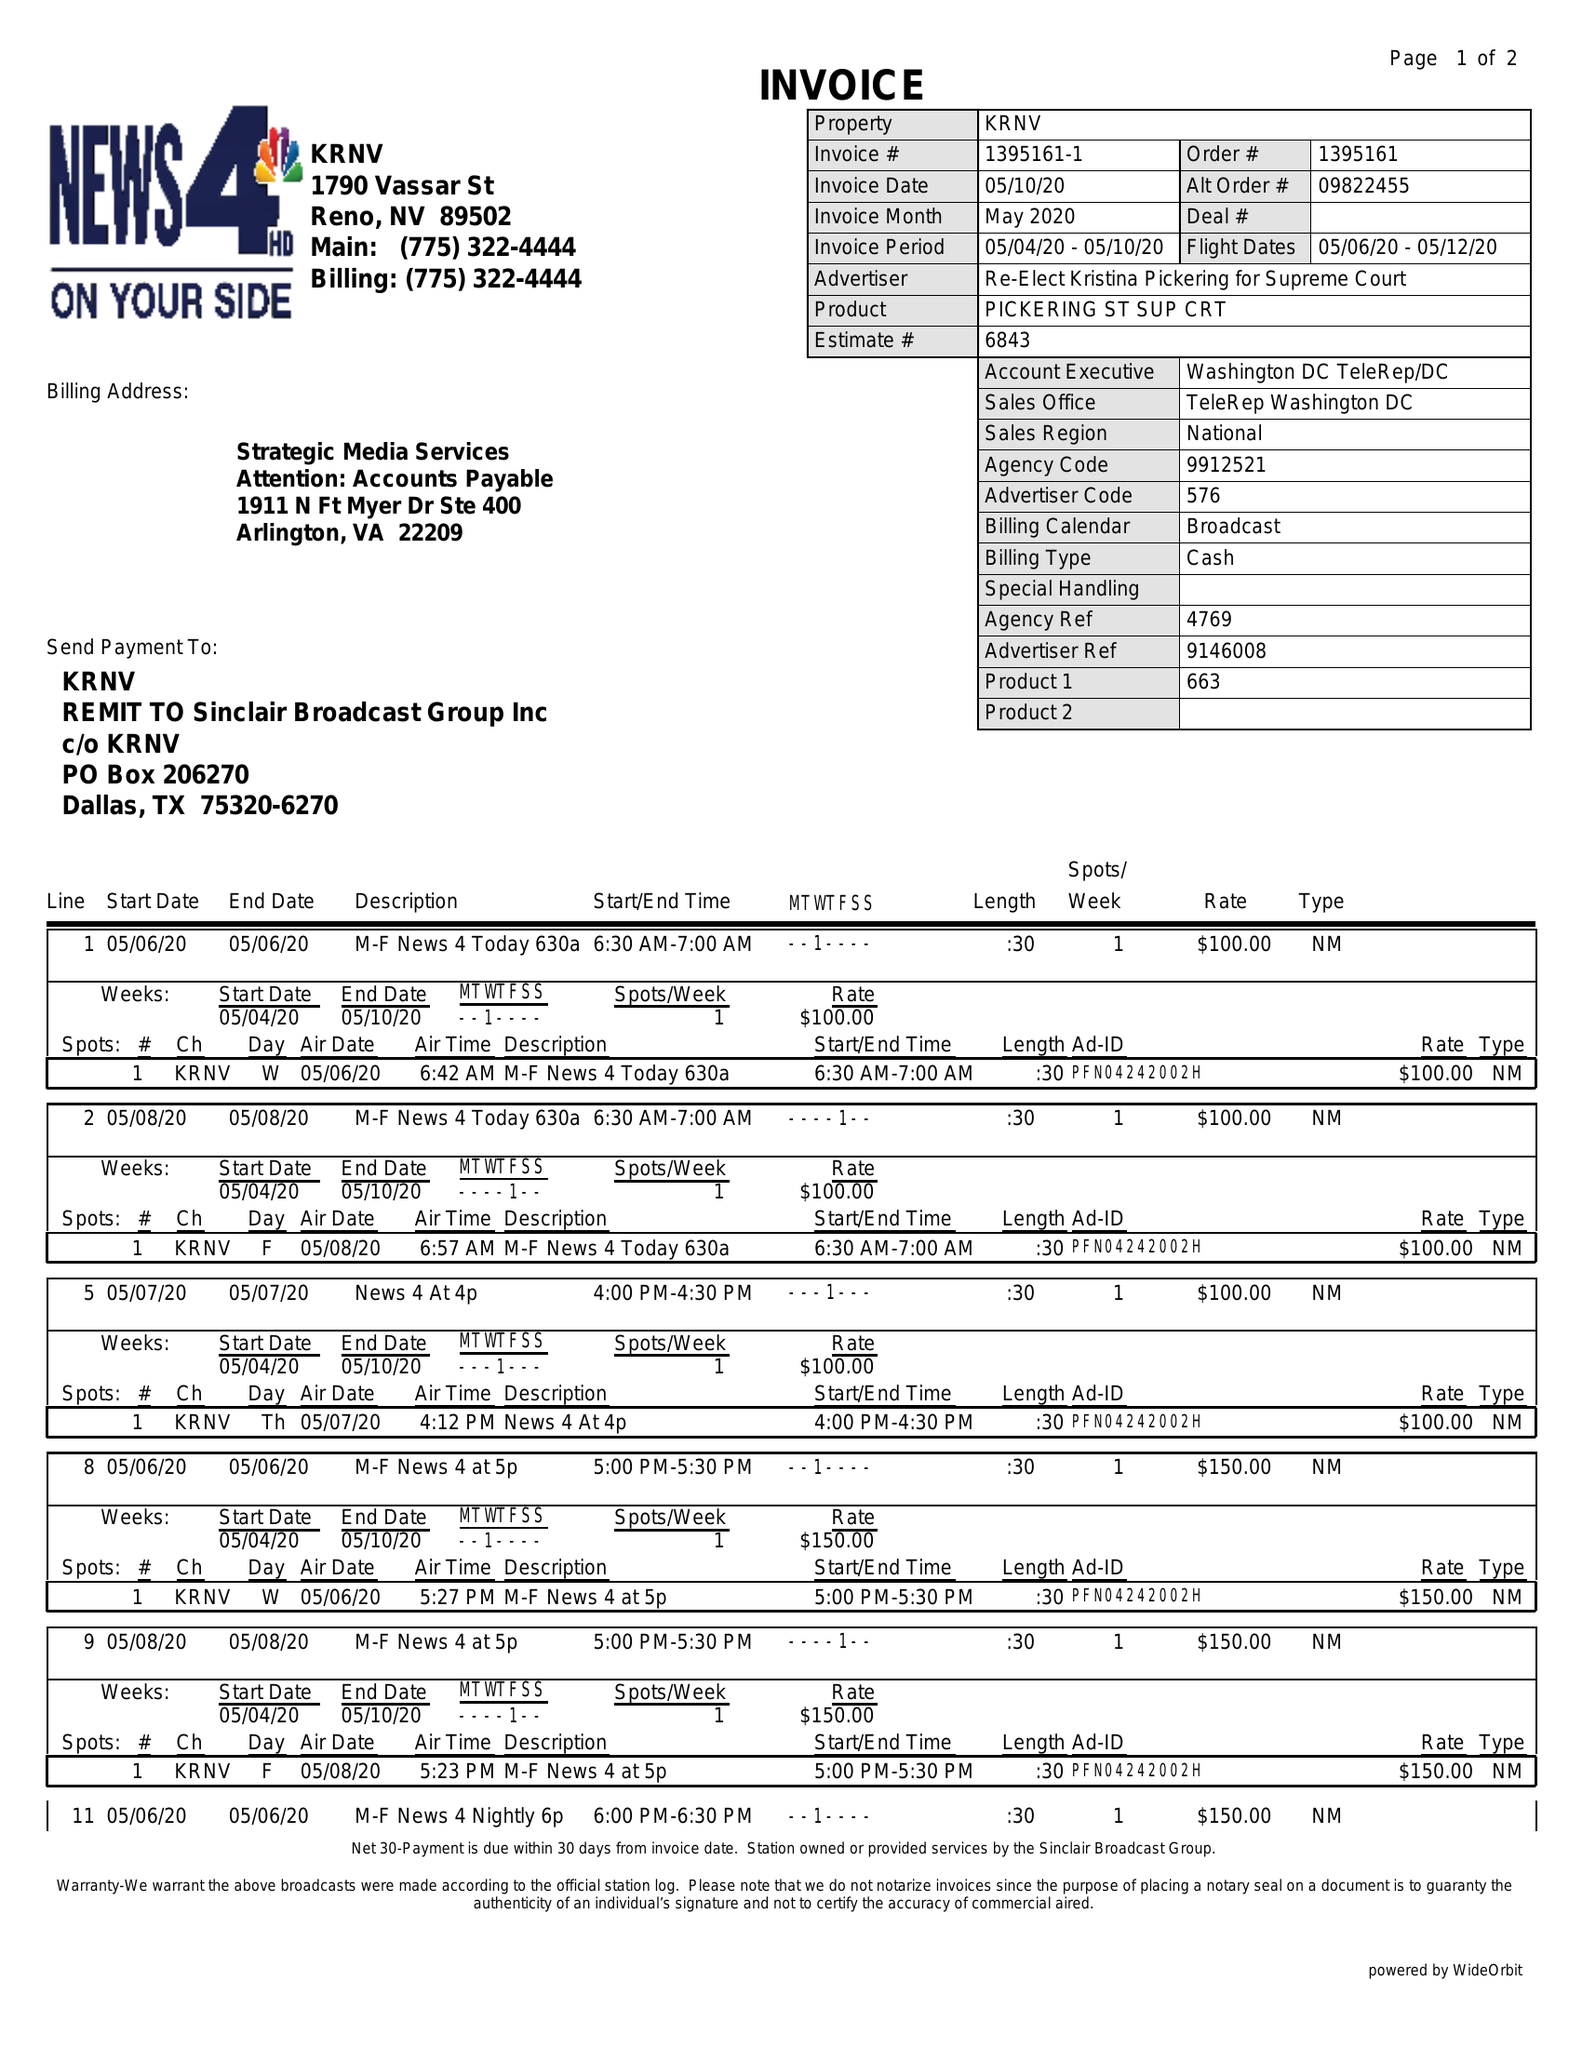What is the value for the advertiser?
Answer the question using a single word or phrase. RE-ELECT KRISTINA PICKERING FOR SUPREME COURT 